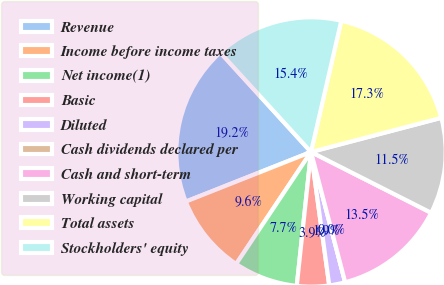<chart> <loc_0><loc_0><loc_500><loc_500><pie_chart><fcel>Revenue<fcel>Income before income taxes<fcel>Net income(1)<fcel>Basic<fcel>Diluted<fcel>Cash dividends declared per<fcel>Cash and short-term<fcel>Working capital<fcel>Total assets<fcel>Stockholders' equity<nl><fcel>19.23%<fcel>9.62%<fcel>7.69%<fcel>3.85%<fcel>1.92%<fcel>0.0%<fcel>13.46%<fcel>11.54%<fcel>17.31%<fcel>15.38%<nl></chart> 